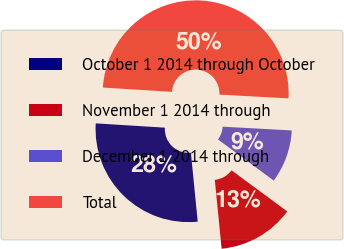Convert chart to OTSL. <chart><loc_0><loc_0><loc_500><loc_500><pie_chart><fcel>October 1 2014 through October<fcel>November 1 2014 through<fcel>December 1 2014 through<fcel>Total<nl><fcel>27.56%<fcel>13.31%<fcel>9.25%<fcel>49.88%<nl></chart> 